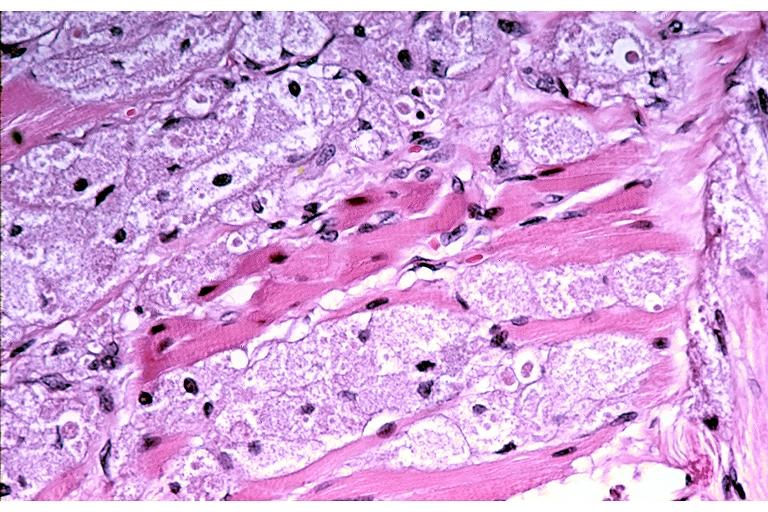does neuronophagia show granular cell tumor?
Answer the question using a single word or phrase. No 